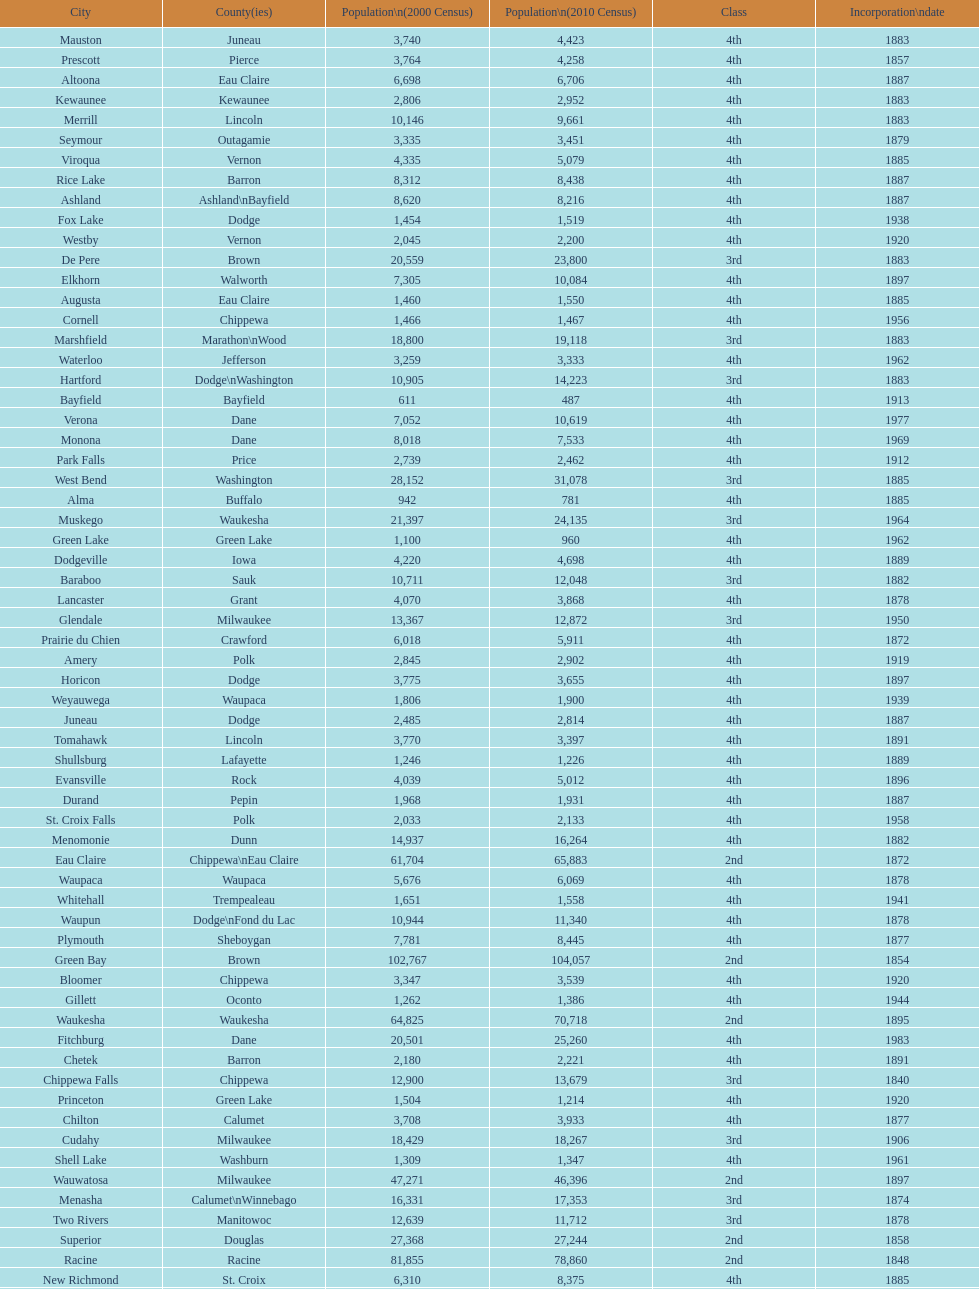What was the first city to be incorporated into wisconsin? Chippewa Falls. 